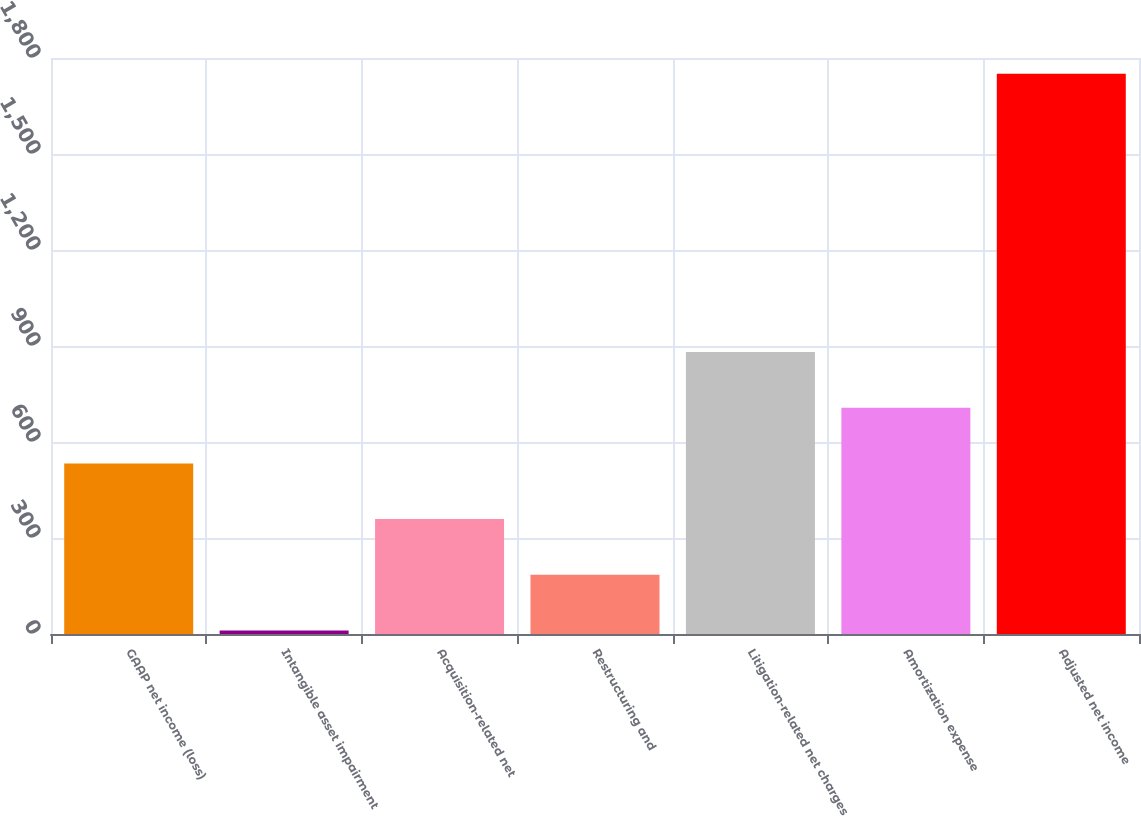Convert chart to OTSL. <chart><loc_0><loc_0><loc_500><loc_500><bar_chart><fcel>GAAP net income (loss)<fcel>Intangible asset impairment<fcel>Acquisition-related net<fcel>Restructuring and<fcel>Litigation-related net charges<fcel>Amortization expense<fcel>Adjusted net income<nl><fcel>533<fcel>11<fcel>359<fcel>185<fcel>881<fcel>707<fcel>1751<nl></chart> 